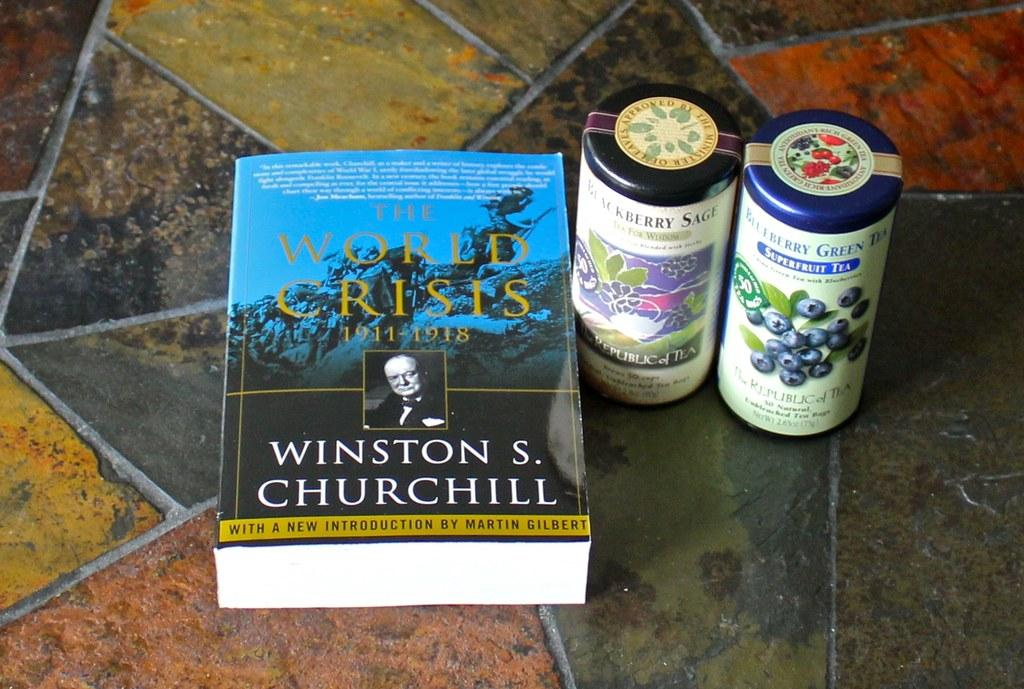<image>
Give a short and clear explanation of the subsequent image. A book titled the World Crisis on a tile tabletop. 